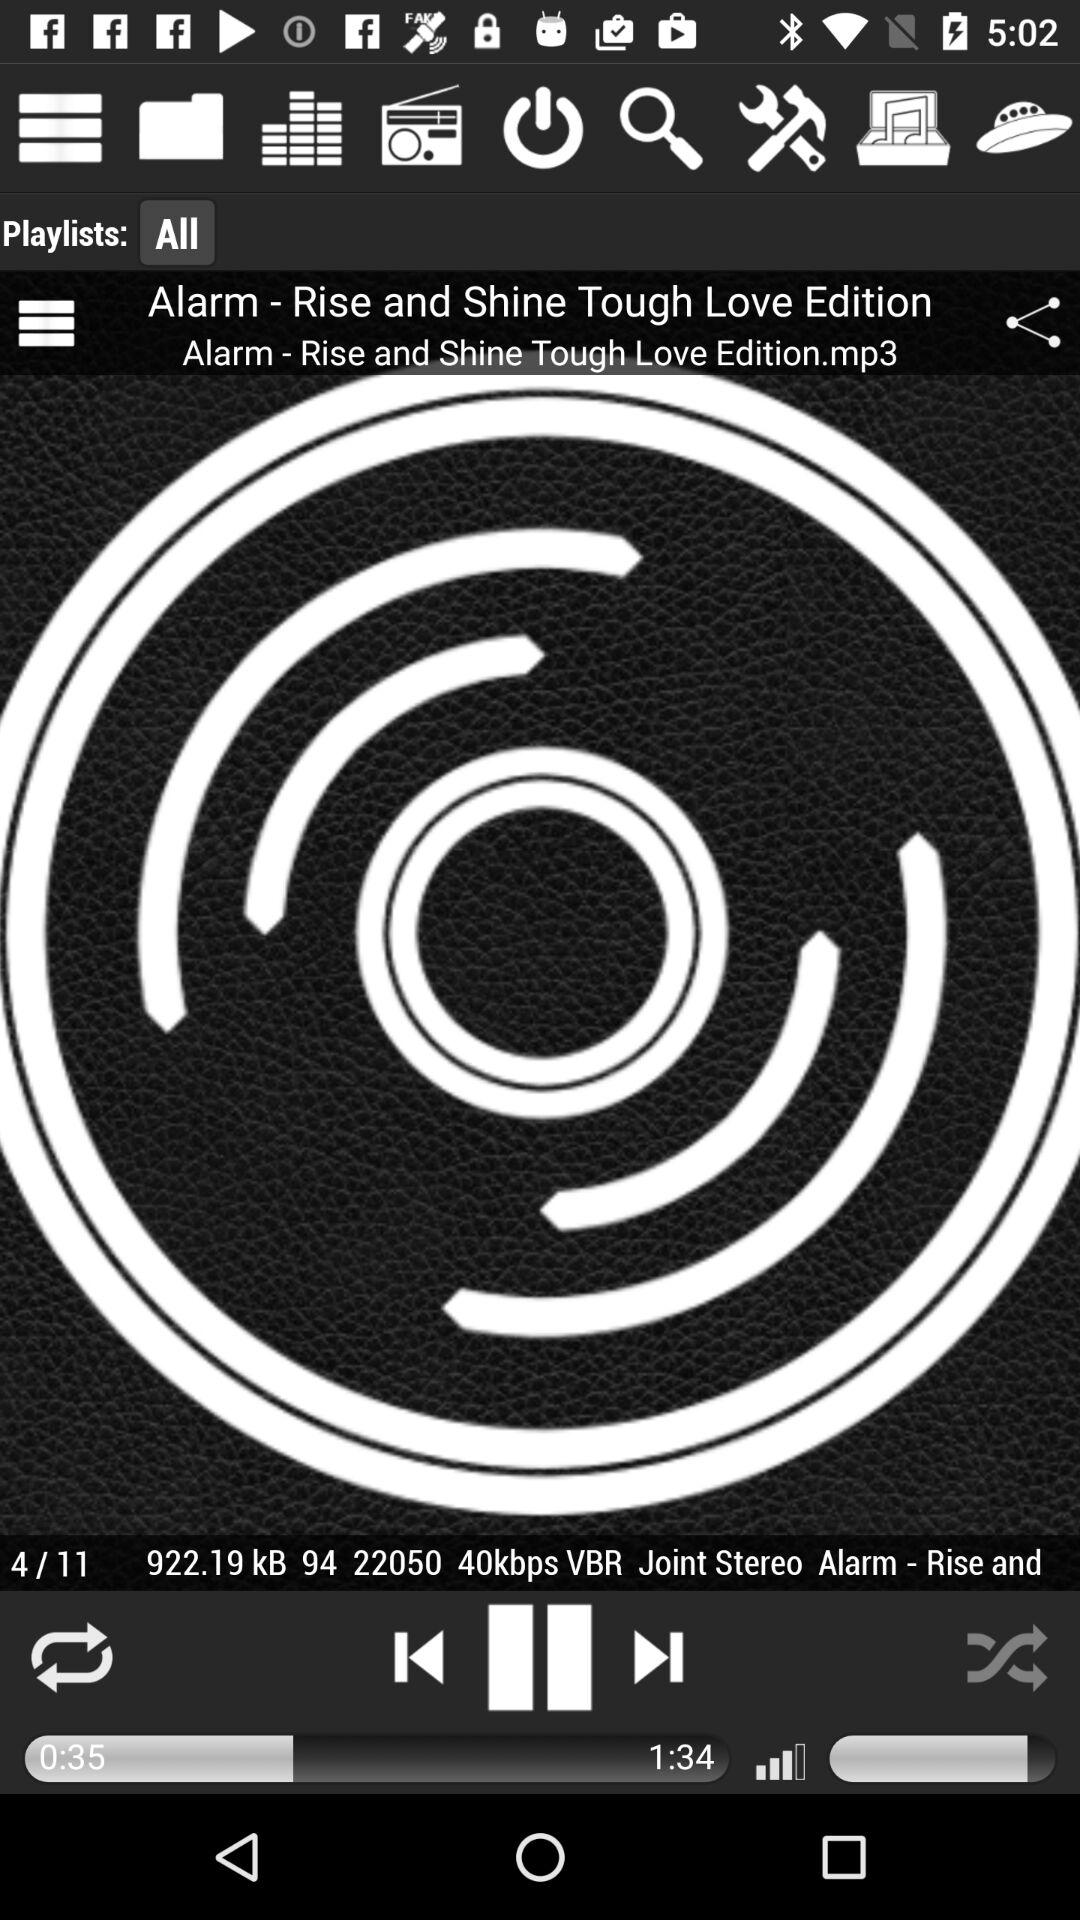Which audio is currently playing? The current playing audio is "Alarm - Rise and Shine Tough Love Edition". 